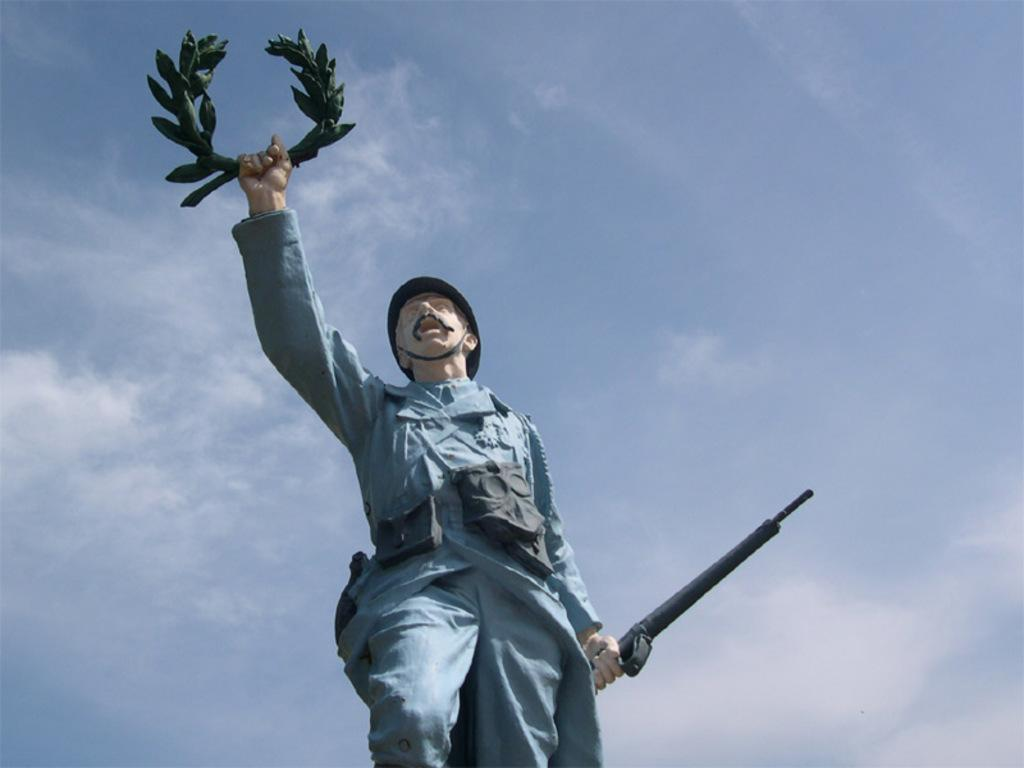What is the main subject of the image? There is a statue of a man in the image. What is the statue holding? The statue is holding a weapon. What is the condition of the sky in the image? The sky is clear in the image. What type of cable can be seen connecting the statue to the bed in the image? There is no cable or bed present in the image; it only features a statue of a man holding a weapon with a clear sky in the background. 